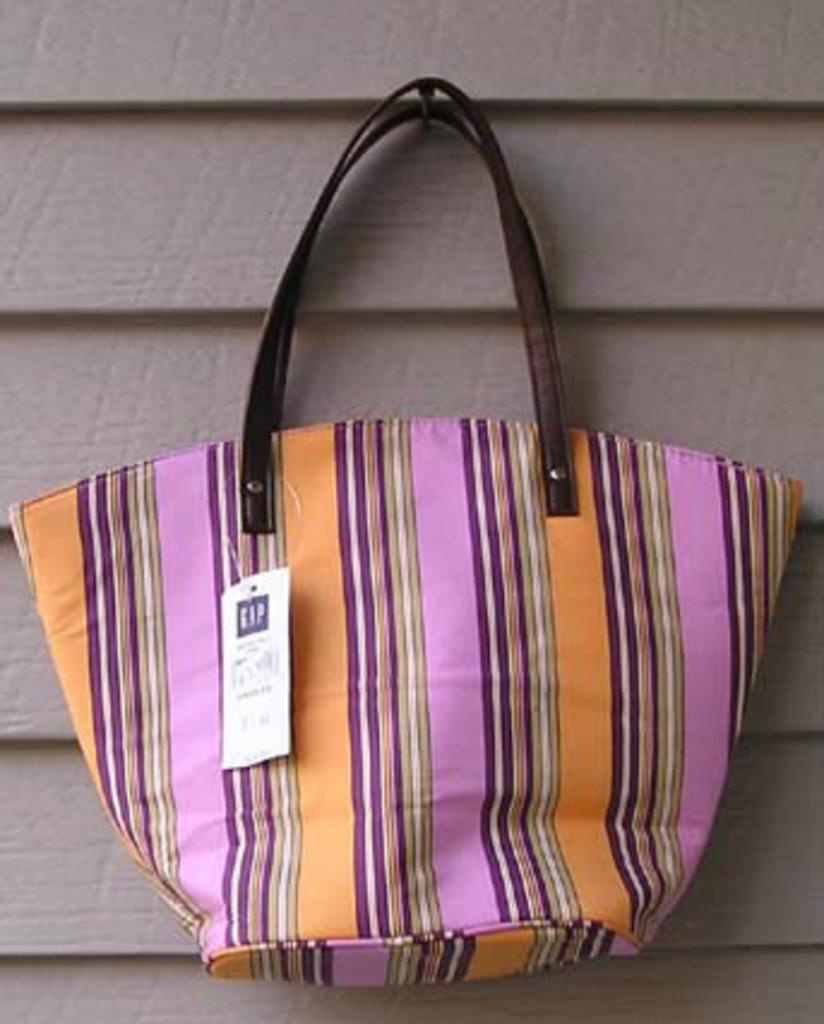What is present in the image that can hold items? There is a bag in the image that can hold items. What colors are visible on the bag? The bag has pink and brown colors. Are there any patterns or designs on the bag? Yes, the bag has lines. Is there any information about the cost of the bag in the image? There is a price tag on the bag. How is the bag positioned in the image? The bag is placed or hooked to a wall. What type of income can be earned from teaching houses in the image? There is no mention of income, teaching, or houses in the image; it only features a bag with lines, pink and brown colors, a price tag, and a wall attachment. 